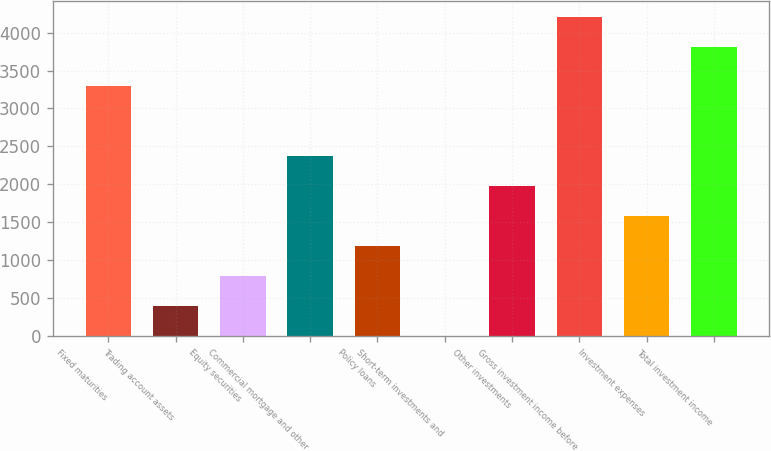<chart> <loc_0><loc_0><loc_500><loc_500><bar_chart><fcel>Fixed maturities<fcel>Trading account assets<fcel>Equity securities<fcel>Commercial mortgage and other<fcel>Policy loans<fcel>Short-term investments and<fcel>Other investments<fcel>Gross investment income before<fcel>Investment expenses<fcel>Total investment income<nl><fcel>3301<fcel>399.7<fcel>795.4<fcel>2378.2<fcel>1191.1<fcel>4<fcel>1982.5<fcel>4203.7<fcel>1586.8<fcel>3808<nl></chart> 